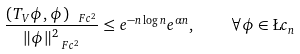<formula> <loc_0><loc_0><loc_500><loc_500>\frac { ( T _ { V } \phi , \phi ) _ { \ F c ^ { 2 } } } { \| \phi \| ^ { 2 } _ { \ F c ^ { 2 } } } \leq e ^ { - n \log n } e ^ { \alpha n } , \quad \forall \phi \in \L c _ { n }</formula> 